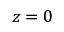Convert formula to latex. <formula><loc_0><loc_0><loc_500><loc_500>z = 0</formula> 